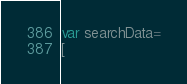Convert code to text. <code><loc_0><loc_0><loc_500><loc_500><_JavaScript_>var searchData=
[</code> 